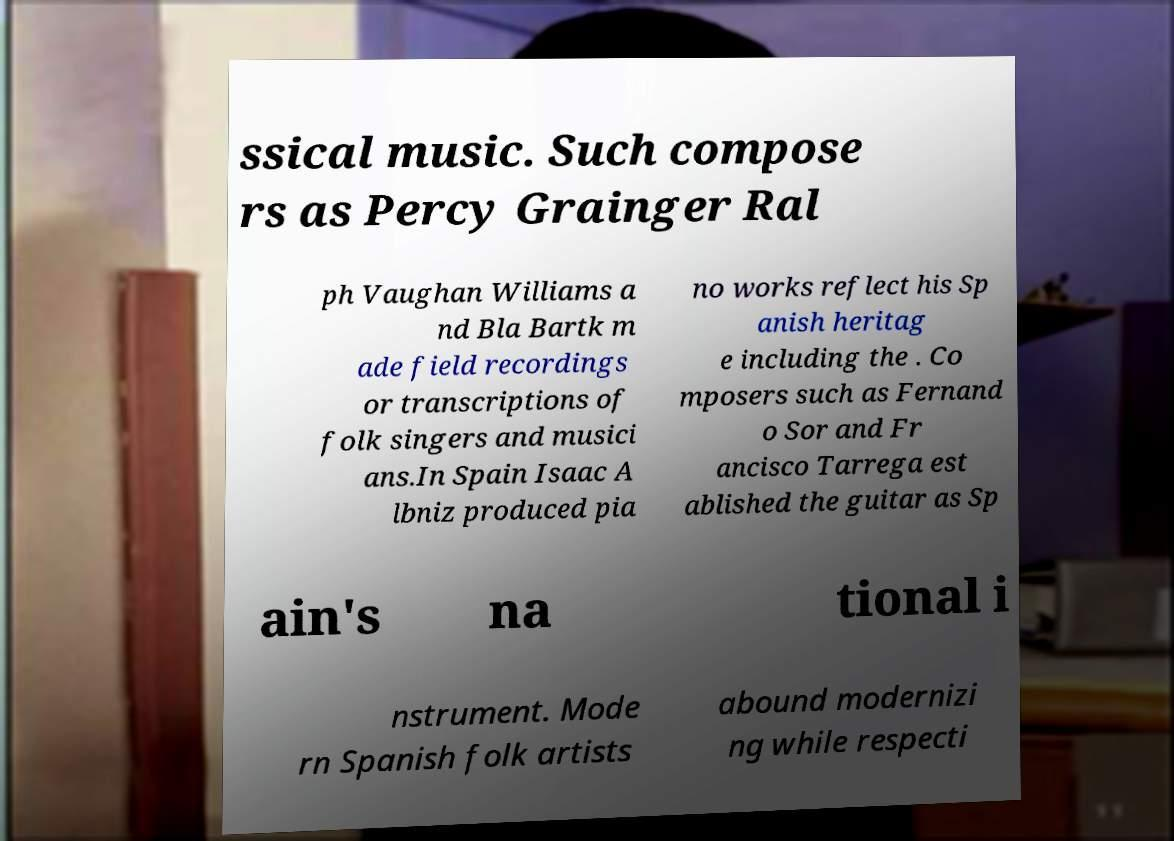Please read and relay the text visible in this image. What does it say? ssical music. Such compose rs as Percy Grainger Ral ph Vaughan Williams a nd Bla Bartk m ade field recordings or transcriptions of folk singers and musici ans.In Spain Isaac A lbniz produced pia no works reflect his Sp anish heritag e including the . Co mposers such as Fernand o Sor and Fr ancisco Tarrega est ablished the guitar as Sp ain's na tional i nstrument. Mode rn Spanish folk artists abound modernizi ng while respecti 